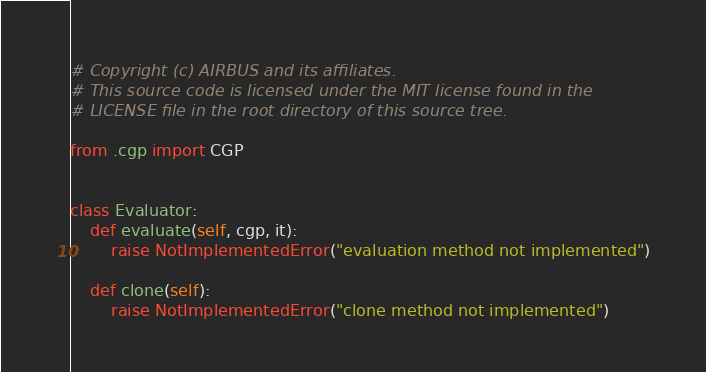<code> <loc_0><loc_0><loc_500><loc_500><_Python_># Copyright (c) AIRBUS and its affiliates.
# This source code is licensed under the MIT license found in the
# LICENSE file in the root directory of this source tree.

from .cgp import CGP


class Evaluator:
    def evaluate(self, cgp, it):
        raise NotImplementedError("evaluation method not implemented")

    def clone(self):
        raise NotImplementedError("clone method not implemented")
</code> 